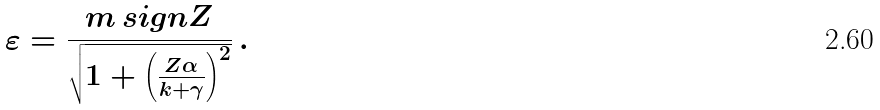Convert formula to latex. <formula><loc_0><loc_0><loc_500><loc_500>\varepsilon = \frac { m \, s i g n Z } { \sqrt { 1 + \left ( \frac { Z \alpha } { k + \gamma } \right ) ^ { 2 } } } \, .</formula> 